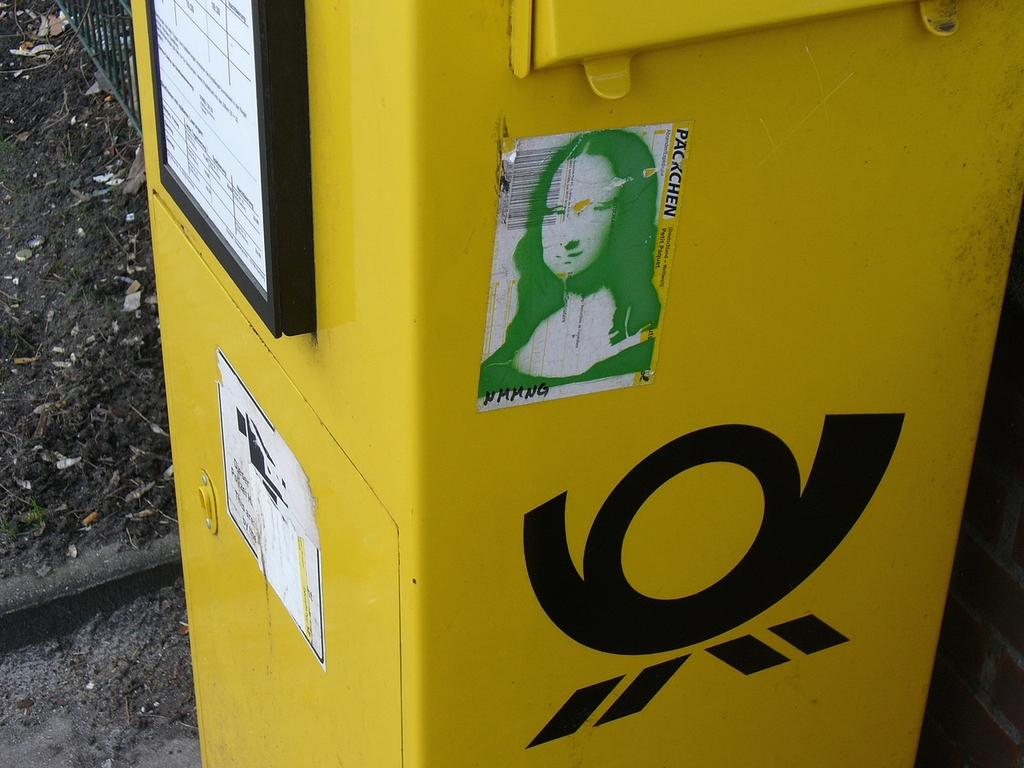<image>
Render a clear and concise summary of the photo. A copy of the Mona Lisa in green has black writing of NMMNG on the bottom corner. 